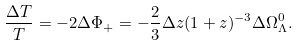<formula> <loc_0><loc_0><loc_500><loc_500>\frac { \Delta T } { T } = - 2 \Delta \Phi _ { + } = - \frac { 2 } { 3 } \Delta z ( 1 + z ) ^ { - 3 } \Delta \Omega _ { \Lambda } ^ { 0 } .</formula> 